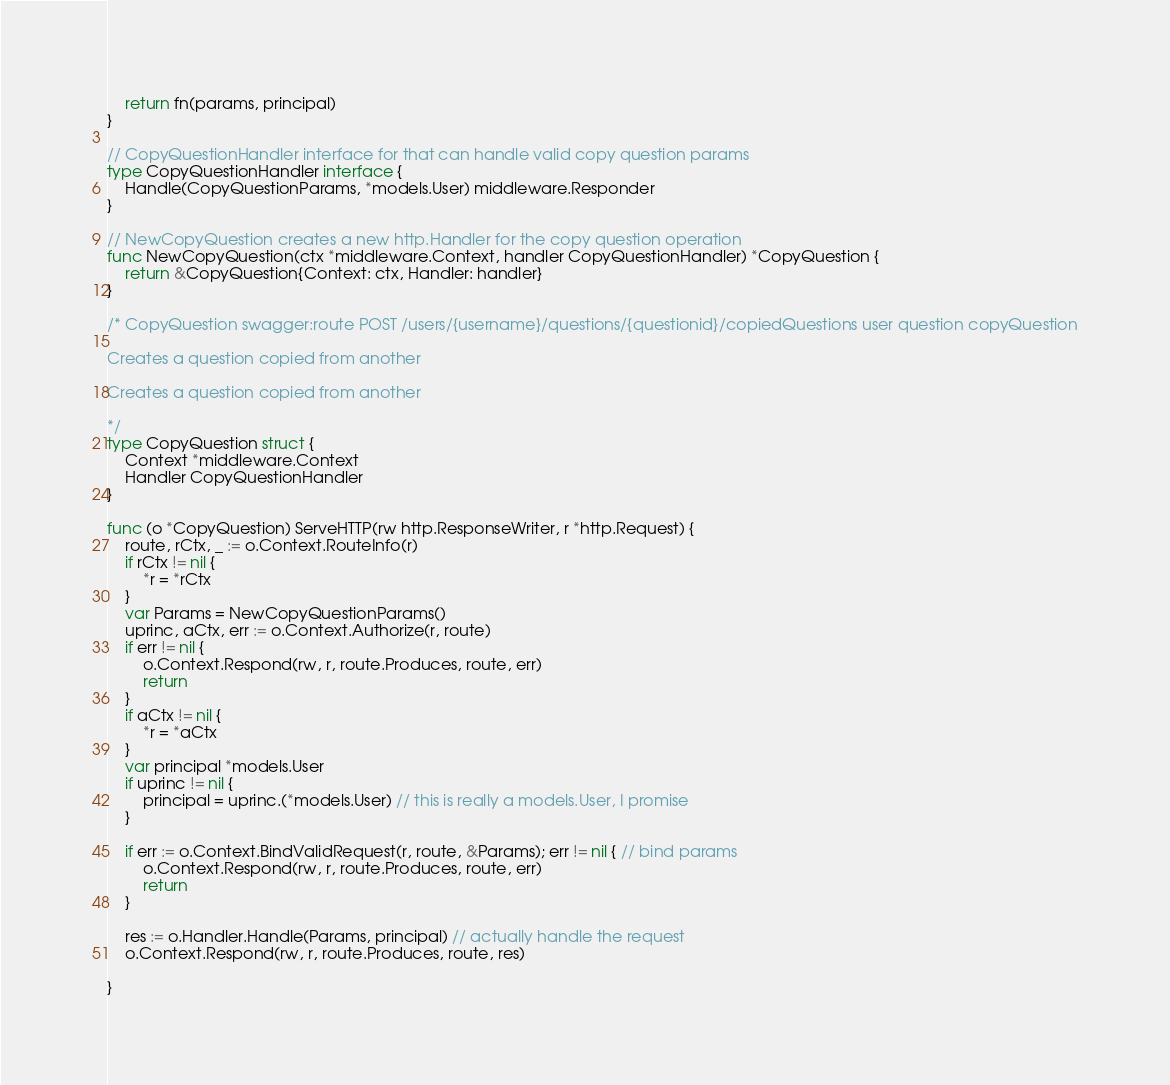Convert code to text. <code><loc_0><loc_0><loc_500><loc_500><_Go_>	return fn(params, principal)
}

// CopyQuestionHandler interface for that can handle valid copy question params
type CopyQuestionHandler interface {
	Handle(CopyQuestionParams, *models.User) middleware.Responder
}

// NewCopyQuestion creates a new http.Handler for the copy question operation
func NewCopyQuestion(ctx *middleware.Context, handler CopyQuestionHandler) *CopyQuestion {
	return &CopyQuestion{Context: ctx, Handler: handler}
}

/* CopyQuestion swagger:route POST /users/{username}/questions/{questionid}/copiedQuestions user question copyQuestion

Creates a question copied from another

Creates a question copied from another

*/
type CopyQuestion struct {
	Context *middleware.Context
	Handler CopyQuestionHandler
}

func (o *CopyQuestion) ServeHTTP(rw http.ResponseWriter, r *http.Request) {
	route, rCtx, _ := o.Context.RouteInfo(r)
	if rCtx != nil {
		*r = *rCtx
	}
	var Params = NewCopyQuestionParams()
	uprinc, aCtx, err := o.Context.Authorize(r, route)
	if err != nil {
		o.Context.Respond(rw, r, route.Produces, route, err)
		return
	}
	if aCtx != nil {
		*r = *aCtx
	}
	var principal *models.User
	if uprinc != nil {
		principal = uprinc.(*models.User) // this is really a models.User, I promise
	}

	if err := o.Context.BindValidRequest(r, route, &Params); err != nil { // bind params
		o.Context.Respond(rw, r, route.Produces, route, err)
		return
	}

	res := o.Handler.Handle(Params, principal) // actually handle the request
	o.Context.Respond(rw, r, route.Produces, route, res)

}
</code> 